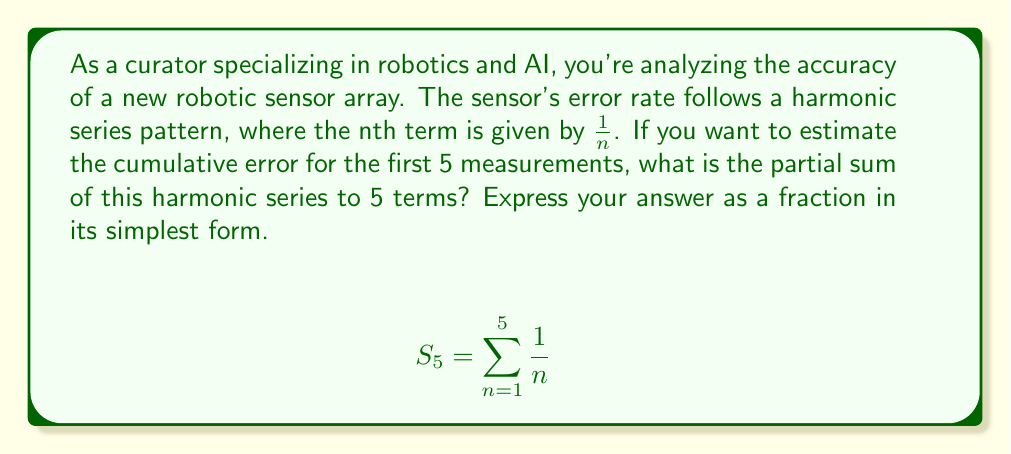Give your solution to this math problem. To solve this problem, we need to calculate the sum of the first 5 terms of the harmonic series:

$$S_5 = \frac{1}{1} + \frac{1}{2} + \frac{1}{3} + \frac{1}{4} + \frac{1}{5}$$

Let's calculate this step-by-step:

1) First, we need to find a common denominator. The least common multiple of 1, 2, 3, 4, and 5 is 60.

2) Now, we'll convert each fraction to an equivalent fraction with denominator 60:

   $$\frac{1}{1} = \frac{60}{60}$$
   $$\frac{1}{2} = \frac{30}{60}$$
   $$\frac{1}{3} = \frac{20}{60}$$
   $$\frac{1}{4} = \frac{15}{60}$$
   $$\frac{1}{5} = \frac{12}{60}$$

3) Now we can add these fractions:

   $$S_5 = \frac{60}{60} + \frac{30}{60} + \frac{20}{60} + \frac{15}{60} + \frac{12}{60}$$

4) Adding the numerators:

   $$S_5 = \frac{60 + 30 + 20 + 15 + 12}{60} = \frac{137}{60}$$

5) This fraction is already in its simplest form, as 137 and 60 have no common factors other than 1.

Therefore, the partial sum of the first 5 terms of this harmonic series is $\frac{137}{60}$.
Answer: $\frac{137}{60}$ 